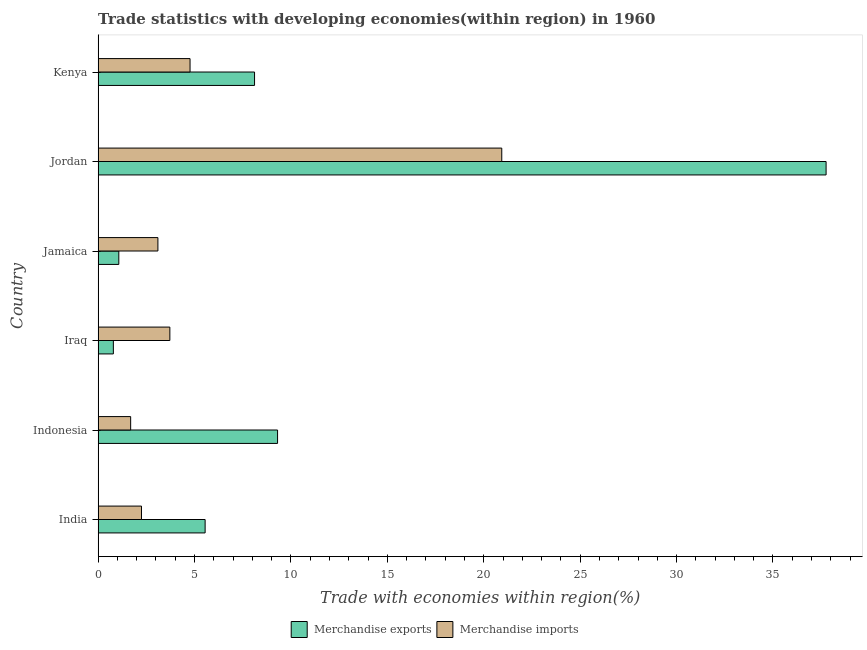How many different coloured bars are there?
Give a very brief answer. 2. How many bars are there on the 5th tick from the top?
Your response must be concise. 2. What is the label of the 2nd group of bars from the top?
Your answer should be very brief. Jordan. In how many cases, is the number of bars for a given country not equal to the number of legend labels?
Ensure brevity in your answer.  0. What is the merchandise imports in Jordan?
Your response must be concise. 20.93. Across all countries, what is the maximum merchandise imports?
Offer a very short reply. 20.93. Across all countries, what is the minimum merchandise imports?
Offer a very short reply. 1.69. In which country was the merchandise exports maximum?
Your response must be concise. Jordan. In which country was the merchandise imports minimum?
Offer a terse response. Indonesia. What is the total merchandise imports in the graph?
Your answer should be compact. 36.46. What is the difference between the merchandise exports in India and that in Jamaica?
Your response must be concise. 4.48. What is the difference between the merchandise imports in Jamaica and the merchandise exports in Indonesia?
Offer a very short reply. -6.21. What is the average merchandise exports per country?
Provide a short and direct response. 10.43. What is the difference between the merchandise exports and merchandise imports in Jamaica?
Provide a succinct answer. -2.03. What is the ratio of the merchandise imports in Jordan to that in Kenya?
Provide a short and direct response. 4.39. What is the difference between the highest and the second highest merchandise exports?
Make the answer very short. 28.45. What is the difference between the highest and the lowest merchandise imports?
Make the answer very short. 19.25. Is the sum of the merchandise exports in Jordan and Kenya greater than the maximum merchandise imports across all countries?
Provide a succinct answer. Yes. What does the 1st bar from the top in Jordan represents?
Provide a short and direct response. Merchandise imports. What does the 2nd bar from the bottom in Jordan represents?
Offer a very short reply. Merchandise imports. How many bars are there?
Give a very brief answer. 12. Are all the bars in the graph horizontal?
Your response must be concise. Yes. What is the difference between two consecutive major ticks on the X-axis?
Offer a very short reply. 5. Where does the legend appear in the graph?
Provide a succinct answer. Bottom center. How are the legend labels stacked?
Give a very brief answer. Horizontal. What is the title of the graph?
Your answer should be very brief. Trade statistics with developing economies(within region) in 1960. Does "Under-five" appear as one of the legend labels in the graph?
Offer a terse response. No. What is the label or title of the X-axis?
Ensure brevity in your answer.  Trade with economies within region(%). What is the Trade with economies within region(%) of Merchandise exports in India?
Your answer should be compact. 5.55. What is the Trade with economies within region(%) in Merchandise imports in India?
Offer a very short reply. 2.25. What is the Trade with economies within region(%) of Merchandise exports in Indonesia?
Your response must be concise. 9.31. What is the Trade with economies within region(%) in Merchandise imports in Indonesia?
Offer a very short reply. 1.69. What is the Trade with economies within region(%) in Merchandise exports in Iraq?
Keep it short and to the point. 0.79. What is the Trade with economies within region(%) of Merchandise imports in Iraq?
Your response must be concise. 3.72. What is the Trade with economies within region(%) of Merchandise exports in Jamaica?
Offer a very short reply. 1.07. What is the Trade with economies within region(%) of Merchandise imports in Jamaica?
Offer a very short reply. 3.1. What is the Trade with economies within region(%) of Merchandise exports in Jordan?
Offer a very short reply. 37.76. What is the Trade with economies within region(%) of Merchandise imports in Jordan?
Provide a succinct answer. 20.93. What is the Trade with economies within region(%) in Merchandise exports in Kenya?
Give a very brief answer. 8.11. What is the Trade with economies within region(%) in Merchandise imports in Kenya?
Give a very brief answer. 4.77. Across all countries, what is the maximum Trade with economies within region(%) of Merchandise exports?
Your response must be concise. 37.76. Across all countries, what is the maximum Trade with economies within region(%) of Merchandise imports?
Provide a short and direct response. 20.93. Across all countries, what is the minimum Trade with economies within region(%) in Merchandise exports?
Make the answer very short. 0.79. Across all countries, what is the minimum Trade with economies within region(%) in Merchandise imports?
Offer a terse response. 1.69. What is the total Trade with economies within region(%) in Merchandise exports in the graph?
Keep it short and to the point. 62.59. What is the total Trade with economies within region(%) in Merchandise imports in the graph?
Provide a short and direct response. 36.46. What is the difference between the Trade with economies within region(%) in Merchandise exports in India and that in Indonesia?
Offer a very short reply. -3.76. What is the difference between the Trade with economies within region(%) in Merchandise imports in India and that in Indonesia?
Ensure brevity in your answer.  0.56. What is the difference between the Trade with economies within region(%) in Merchandise exports in India and that in Iraq?
Provide a succinct answer. 4.76. What is the difference between the Trade with economies within region(%) in Merchandise imports in India and that in Iraq?
Your response must be concise. -1.47. What is the difference between the Trade with economies within region(%) of Merchandise exports in India and that in Jamaica?
Your answer should be compact. 4.48. What is the difference between the Trade with economies within region(%) of Merchandise imports in India and that in Jamaica?
Your answer should be compact. -0.85. What is the difference between the Trade with economies within region(%) of Merchandise exports in India and that in Jordan?
Make the answer very short. -32.2. What is the difference between the Trade with economies within region(%) of Merchandise imports in India and that in Jordan?
Offer a terse response. -18.68. What is the difference between the Trade with economies within region(%) of Merchandise exports in India and that in Kenya?
Provide a succinct answer. -2.56. What is the difference between the Trade with economies within region(%) of Merchandise imports in India and that in Kenya?
Your response must be concise. -2.52. What is the difference between the Trade with economies within region(%) in Merchandise exports in Indonesia and that in Iraq?
Your answer should be very brief. 8.52. What is the difference between the Trade with economies within region(%) of Merchandise imports in Indonesia and that in Iraq?
Provide a short and direct response. -2.03. What is the difference between the Trade with economies within region(%) in Merchandise exports in Indonesia and that in Jamaica?
Ensure brevity in your answer.  8.23. What is the difference between the Trade with economies within region(%) in Merchandise imports in Indonesia and that in Jamaica?
Give a very brief answer. -1.41. What is the difference between the Trade with economies within region(%) in Merchandise exports in Indonesia and that in Jordan?
Your response must be concise. -28.45. What is the difference between the Trade with economies within region(%) in Merchandise imports in Indonesia and that in Jordan?
Give a very brief answer. -19.25. What is the difference between the Trade with economies within region(%) of Merchandise exports in Indonesia and that in Kenya?
Provide a succinct answer. 1.19. What is the difference between the Trade with economies within region(%) of Merchandise imports in Indonesia and that in Kenya?
Give a very brief answer. -3.08. What is the difference between the Trade with economies within region(%) of Merchandise exports in Iraq and that in Jamaica?
Provide a succinct answer. -0.28. What is the difference between the Trade with economies within region(%) of Merchandise imports in Iraq and that in Jamaica?
Provide a short and direct response. 0.62. What is the difference between the Trade with economies within region(%) of Merchandise exports in Iraq and that in Jordan?
Provide a short and direct response. -36.96. What is the difference between the Trade with economies within region(%) in Merchandise imports in Iraq and that in Jordan?
Make the answer very short. -17.21. What is the difference between the Trade with economies within region(%) of Merchandise exports in Iraq and that in Kenya?
Your answer should be compact. -7.32. What is the difference between the Trade with economies within region(%) in Merchandise imports in Iraq and that in Kenya?
Keep it short and to the point. -1.05. What is the difference between the Trade with economies within region(%) in Merchandise exports in Jamaica and that in Jordan?
Provide a succinct answer. -36.68. What is the difference between the Trade with economies within region(%) in Merchandise imports in Jamaica and that in Jordan?
Provide a succinct answer. -17.83. What is the difference between the Trade with economies within region(%) in Merchandise exports in Jamaica and that in Kenya?
Ensure brevity in your answer.  -7.04. What is the difference between the Trade with economies within region(%) of Merchandise imports in Jamaica and that in Kenya?
Provide a short and direct response. -1.67. What is the difference between the Trade with economies within region(%) of Merchandise exports in Jordan and that in Kenya?
Provide a short and direct response. 29.64. What is the difference between the Trade with economies within region(%) in Merchandise imports in Jordan and that in Kenya?
Make the answer very short. 16.17. What is the difference between the Trade with economies within region(%) of Merchandise exports in India and the Trade with economies within region(%) of Merchandise imports in Indonesia?
Keep it short and to the point. 3.86. What is the difference between the Trade with economies within region(%) of Merchandise exports in India and the Trade with economies within region(%) of Merchandise imports in Iraq?
Offer a terse response. 1.83. What is the difference between the Trade with economies within region(%) in Merchandise exports in India and the Trade with economies within region(%) in Merchandise imports in Jamaica?
Offer a very short reply. 2.45. What is the difference between the Trade with economies within region(%) of Merchandise exports in India and the Trade with economies within region(%) of Merchandise imports in Jordan?
Provide a succinct answer. -15.38. What is the difference between the Trade with economies within region(%) in Merchandise exports in India and the Trade with economies within region(%) in Merchandise imports in Kenya?
Make the answer very short. 0.78. What is the difference between the Trade with economies within region(%) in Merchandise exports in Indonesia and the Trade with economies within region(%) in Merchandise imports in Iraq?
Provide a succinct answer. 5.59. What is the difference between the Trade with economies within region(%) of Merchandise exports in Indonesia and the Trade with economies within region(%) of Merchandise imports in Jamaica?
Ensure brevity in your answer.  6.21. What is the difference between the Trade with economies within region(%) in Merchandise exports in Indonesia and the Trade with economies within region(%) in Merchandise imports in Jordan?
Keep it short and to the point. -11.63. What is the difference between the Trade with economies within region(%) of Merchandise exports in Indonesia and the Trade with economies within region(%) of Merchandise imports in Kenya?
Your answer should be compact. 4.54. What is the difference between the Trade with economies within region(%) in Merchandise exports in Iraq and the Trade with economies within region(%) in Merchandise imports in Jamaica?
Keep it short and to the point. -2.31. What is the difference between the Trade with economies within region(%) of Merchandise exports in Iraq and the Trade with economies within region(%) of Merchandise imports in Jordan?
Ensure brevity in your answer.  -20.14. What is the difference between the Trade with economies within region(%) of Merchandise exports in Iraq and the Trade with economies within region(%) of Merchandise imports in Kenya?
Give a very brief answer. -3.98. What is the difference between the Trade with economies within region(%) of Merchandise exports in Jamaica and the Trade with economies within region(%) of Merchandise imports in Jordan?
Your answer should be very brief. -19.86. What is the difference between the Trade with economies within region(%) in Merchandise exports in Jamaica and the Trade with economies within region(%) in Merchandise imports in Kenya?
Make the answer very short. -3.69. What is the difference between the Trade with economies within region(%) of Merchandise exports in Jordan and the Trade with economies within region(%) of Merchandise imports in Kenya?
Your response must be concise. 32.99. What is the average Trade with economies within region(%) of Merchandise exports per country?
Give a very brief answer. 10.43. What is the average Trade with economies within region(%) in Merchandise imports per country?
Provide a short and direct response. 6.08. What is the difference between the Trade with economies within region(%) of Merchandise exports and Trade with economies within region(%) of Merchandise imports in India?
Offer a very short reply. 3.3. What is the difference between the Trade with economies within region(%) of Merchandise exports and Trade with economies within region(%) of Merchandise imports in Indonesia?
Your answer should be compact. 7.62. What is the difference between the Trade with economies within region(%) of Merchandise exports and Trade with economies within region(%) of Merchandise imports in Iraq?
Your response must be concise. -2.93. What is the difference between the Trade with economies within region(%) in Merchandise exports and Trade with economies within region(%) in Merchandise imports in Jamaica?
Offer a very short reply. -2.03. What is the difference between the Trade with economies within region(%) of Merchandise exports and Trade with economies within region(%) of Merchandise imports in Jordan?
Your answer should be compact. 16.82. What is the difference between the Trade with economies within region(%) in Merchandise exports and Trade with economies within region(%) in Merchandise imports in Kenya?
Offer a terse response. 3.35. What is the ratio of the Trade with economies within region(%) in Merchandise exports in India to that in Indonesia?
Provide a succinct answer. 0.6. What is the ratio of the Trade with economies within region(%) in Merchandise imports in India to that in Indonesia?
Your answer should be very brief. 1.33. What is the ratio of the Trade with economies within region(%) of Merchandise exports in India to that in Iraq?
Provide a short and direct response. 7.02. What is the ratio of the Trade with economies within region(%) in Merchandise imports in India to that in Iraq?
Provide a short and direct response. 0.6. What is the ratio of the Trade with economies within region(%) in Merchandise exports in India to that in Jamaica?
Make the answer very short. 5.17. What is the ratio of the Trade with economies within region(%) in Merchandise imports in India to that in Jamaica?
Make the answer very short. 0.73. What is the ratio of the Trade with economies within region(%) in Merchandise exports in India to that in Jordan?
Provide a short and direct response. 0.15. What is the ratio of the Trade with economies within region(%) of Merchandise imports in India to that in Jordan?
Provide a succinct answer. 0.11. What is the ratio of the Trade with economies within region(%) of Merchandise exports in India to that in Kenya?
Make the answer very short. 0.68. What is the ratio of the Trade with economies within region(%) in Merchandise imports in India to that in Kenya?
Ensure brevity in your answer.  0.47. What is the ratio of the Trade with economies within region(%) in Merchandise exports in Indonesia to that in Iraq?
Your answer should be compact. 11.78. What is the ratio of the Trade with economies within region(%) in Merchandise imports in Indonesia to that in Iraq?
Keep it short and to the point. 0.45. What is the ratio of the Trade with economies within region(%) in Merchandise exports in Indonesia to that in Jamaica?
Offer a terse response. 8.67. What is the ratio of the Trade with economies within region(%) of Merchandise imports in Indonesia to that in Jamaica?
Give a very brief answer. 0.54. What is the ratio of the Trade with economies within region(%) in Merchandise exports in Indonesia to that in Jordan?
Offer a very short reply. 0.25. What is the ratio of the Trade with economies within region(%) in Merchandise imports in Indonesia to that in Jordan?
Your answer should be very brief. 0.08. What is the ratio of the Trade with economies within region(%) of Merchandise exports in Indonesia to that in Kenya?
Make the answer very short. 1.15. What is the ratio of the Trade with economies within region(%) in Merchandise imports in Indonesia to that in Kenya?
Offer a terse response. 0.35. What is the ratio of the Trade with economies within region(%) in Merchandise exports in Iraq to that in Jamaica?
Ensure brevity in your answer.  0.74. What is the ratio of the Trade with economies within region(%) of Merchandise imports in Iraq to that in Jamaica?
Your response must be concise. 1.2. What is the ratio of the Trade with economies within region(%) of Merchandise exports in Iraq to that in Jordan?
Provide a succinct answer. 0.02. What is the ratio of the Trade with economies within region(%) of Merchandise imports in Iraq to that in Jordan?
Your answer should be very brief. 0.18. What is the ratio of the Trade with economies within region(%) of Merchandise exports in Iraq to that in Kenya?
Your answer should be very brief. 0.1. What is the ratio of the Trade with economies within region(%) in Merchandise imports in Iraq to that in Kenya?
Keep it short and to the point. 0.78. What is the ratio of the Trade with economies within region(%) in Merchandise exports in Jamaica to that in Jordan?
Your answer should be very brief. 0.03. What is the ratio of the Trade with economies within region(%) in Merchandise imports in Jamaica to that in Jordan?
Ensure brevity in your answer.  0.15. What is the ratio of the Trade with economies within region(%) in Merchandise exports in Jamaica to that in Kenya?
Provide a short and direct response. 0.13. What is the ratio of the Trade with economies within region(%) of Merchandise imports in Jamaica to that in Kenya?
Provide a succinct answer. 0.65. What is the ratio of the Trade with economies within region(%) in Merchandise exports in Jordan to that in Kenya?
Provide a succinct answer. 4.65. What is the ratio of the Trade with economies within region(%) in Merchandise imports in Jordan to that in Kenya?
Your answer should be very brief. 4.39. What is the difference between the highest and the second highest Trade with economies within region(%) of Merchandise exports?
Your answer should be compact. 28.45. What is the difference between the highest and the second highest Trade with economies within region(%) in Merchandise imports?
Your answer should be compact. 16.17. What is the difference between the highest and the lowest Trade with economies within region(%) in Merchandise exports?
Your answer should be very brief. 36.96. What is the difference between the highest and the lowest Trade with economies within region(%) in Merchandise imports?
Offer a very short reply. 19.25. 